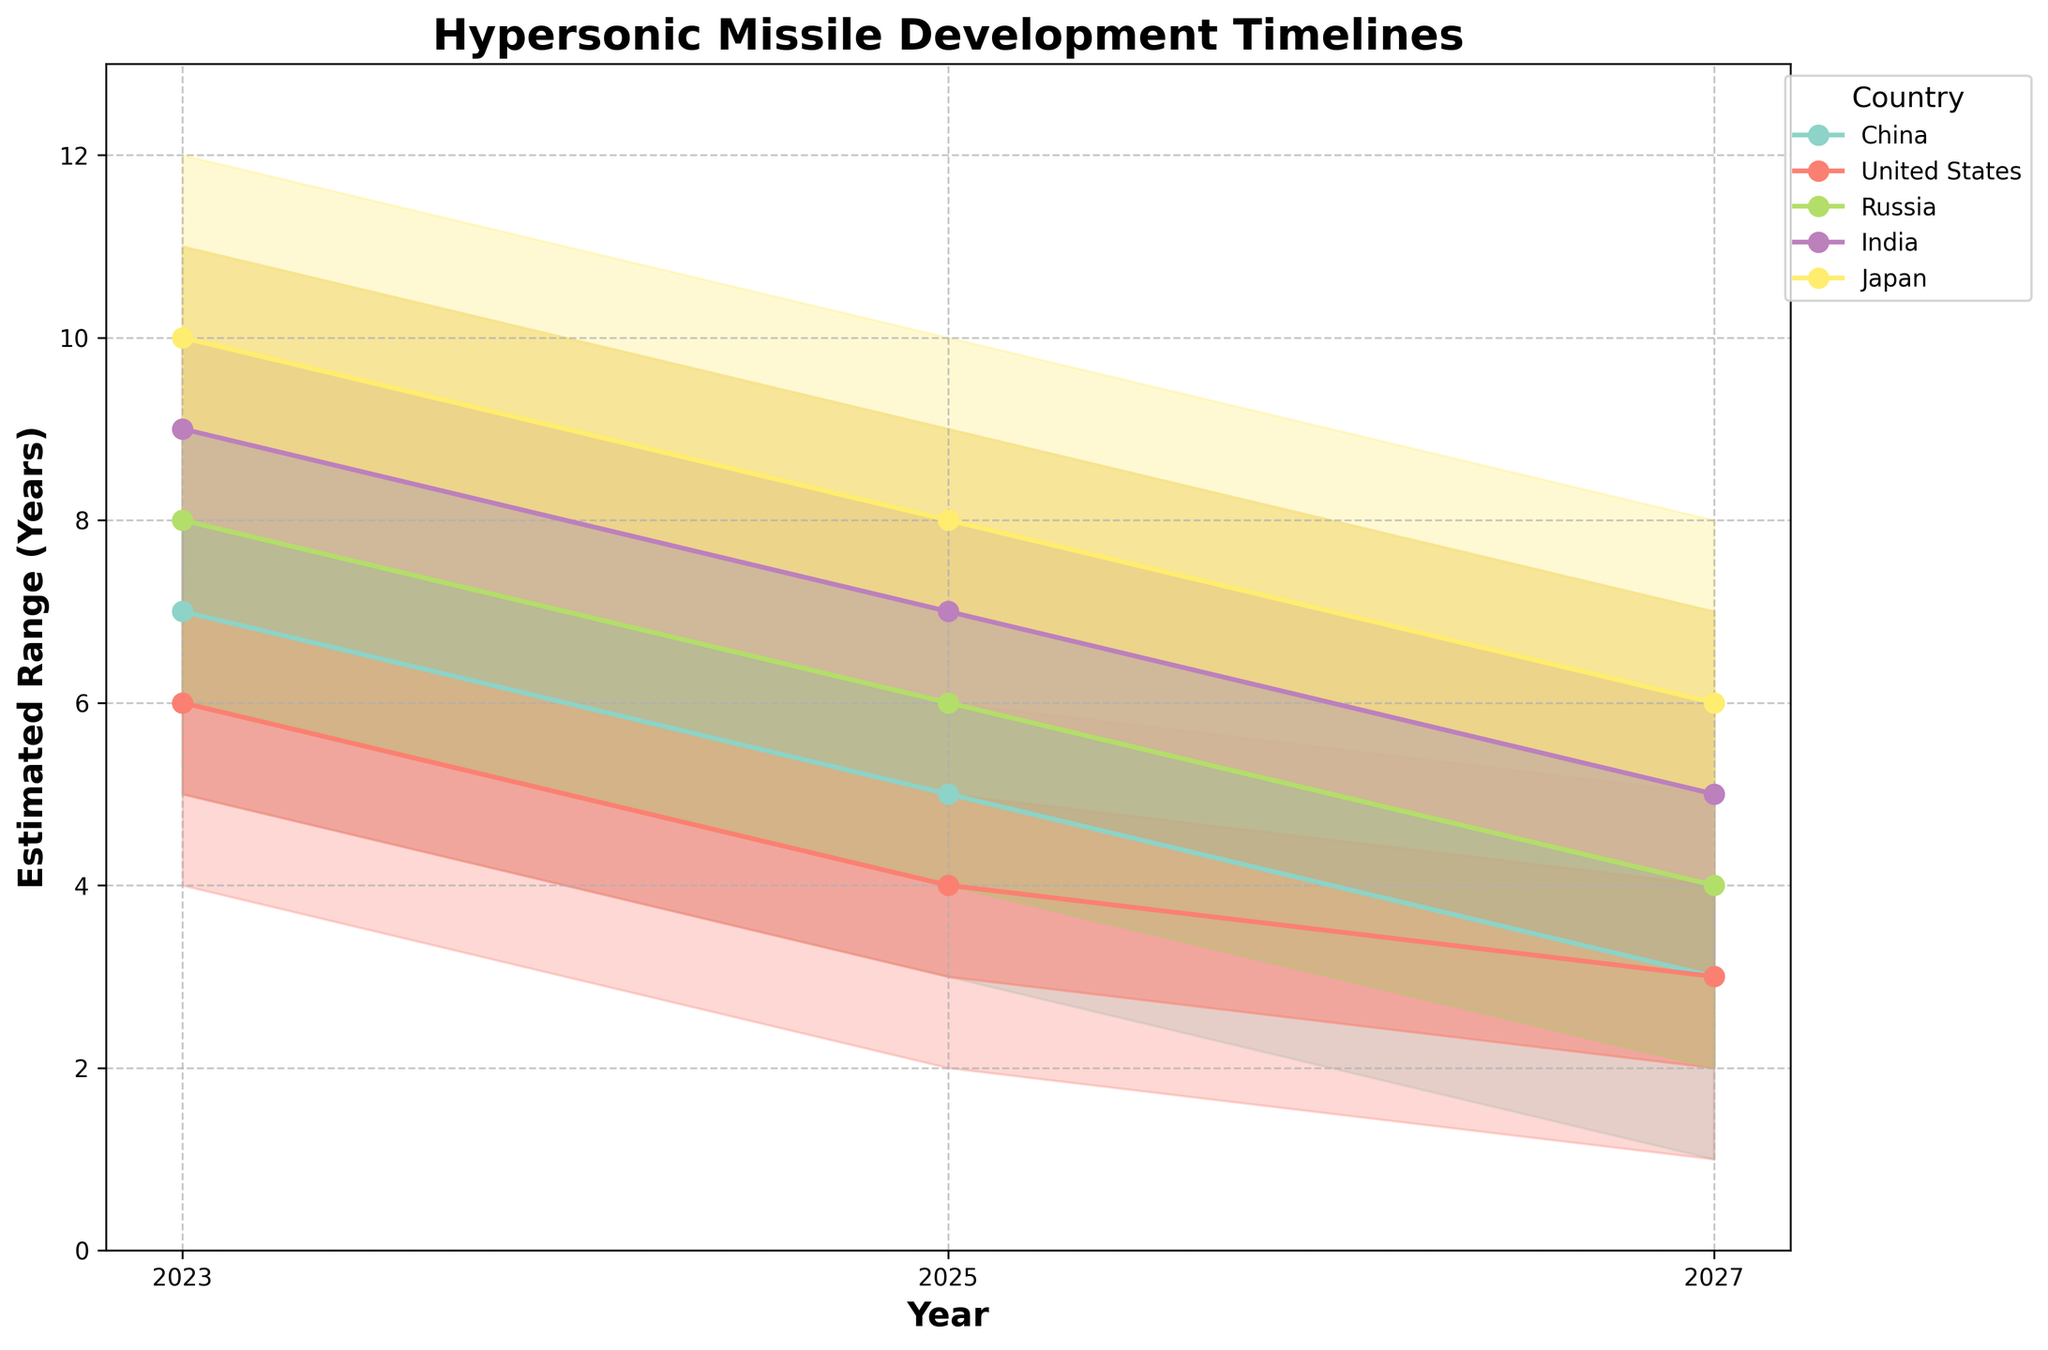What's the title of the chart? The title is written at the top of the chart. It reads "Hypersonic Missile Development Timelines".
Answer: Hypersonic Missile Development Timelines Which country has the highest estimated range for hypersonic missile development in 2023? Look at the top boundary of the fan in 2023 for each country. Japan's highest estimated range for 2023 reaches 12.
Answer: Japan Between China and the United States, which country has a lower mid-range estimate in 2025? The mid-range estimate for a country is represented by the middle line of the fan. For 2025, China has a mid-range estimate of 5, and the United States has a mid-range estimate of 4.
Answer: United States How many countries are represented in the chart? The legend on the chart lists each country represented. Count the countries listed there.
Answer: 5 What is the lower estimate for India's missile development timeline in 2027? Identify India's fan for 2027, and note the lower boundary which represents the lower estimate. The lower estimate for India in 2027 is 3.
Answer: 3 What trend can be observed for China’s missile development timelines from 2023 to 2027? Look at the progression of China's estimates from 2023 to 2027. There is a decrease in estimates, evidenced by falling lines. 2023 shows a low estimate of 5 while 2027 shows a low estimate of 1.
Answer: Falling trends In which year does Russia have an estimated range shifting from low-mid to mid-high between 8 and 9 years? Check Russia's fan chart for all years to find when the range of low-mid and mid-high values intersect at 8 and 9 years. This happens in 2023.
Answer: 2023 Which year and country combination shows the tightest range of estimates for missile development? A tight range of estimates occurs when the gap between low and high, and low-mid and mid-high is small. For the given years, both China and the United States in 2027 show a range of 1 to 5 years.
Answer: China and United States in 2027 Considering the mid-range values, which country shows the most significant decline from 2023 to 2027? Calculate the difference between mid-range values between 2023 and 2027 for each country. China declines from 7 in 2023 to 3 in 2027, a significant drop of 4 years.
Answer: China 